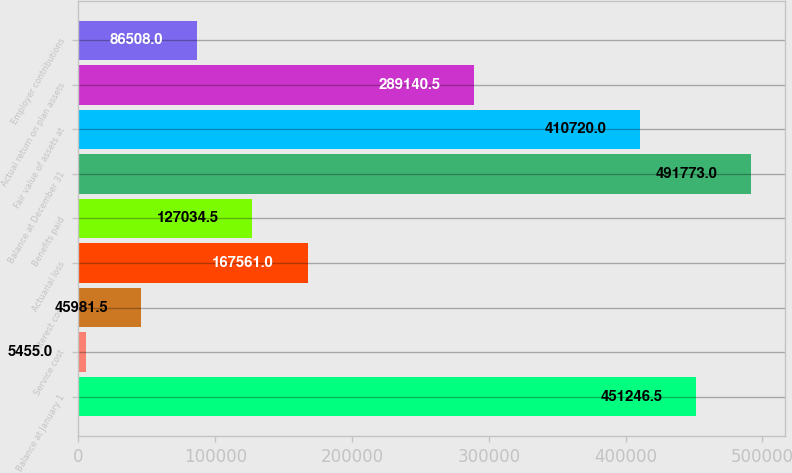Convert chart. <chart><loc_0><loc_0><loc_500><loc_500><bar_chart><fcel>Balance at January 1<fcel>Service cost<fcel>Interest cost<fcel>Actuarial loss<fcel>Benefits paid<fcel>Balance at December 31<fcel>Fair value of assets at<fcel>Actual return on plan assets<fcel>Employer contributions<nl><fcel>451246<fcel>5455<fcel>45981.5<fcel>167561<fcel>127034<fcel>491773<fcel>410720<fcel>289140<fcel>86508<nl></chart> 